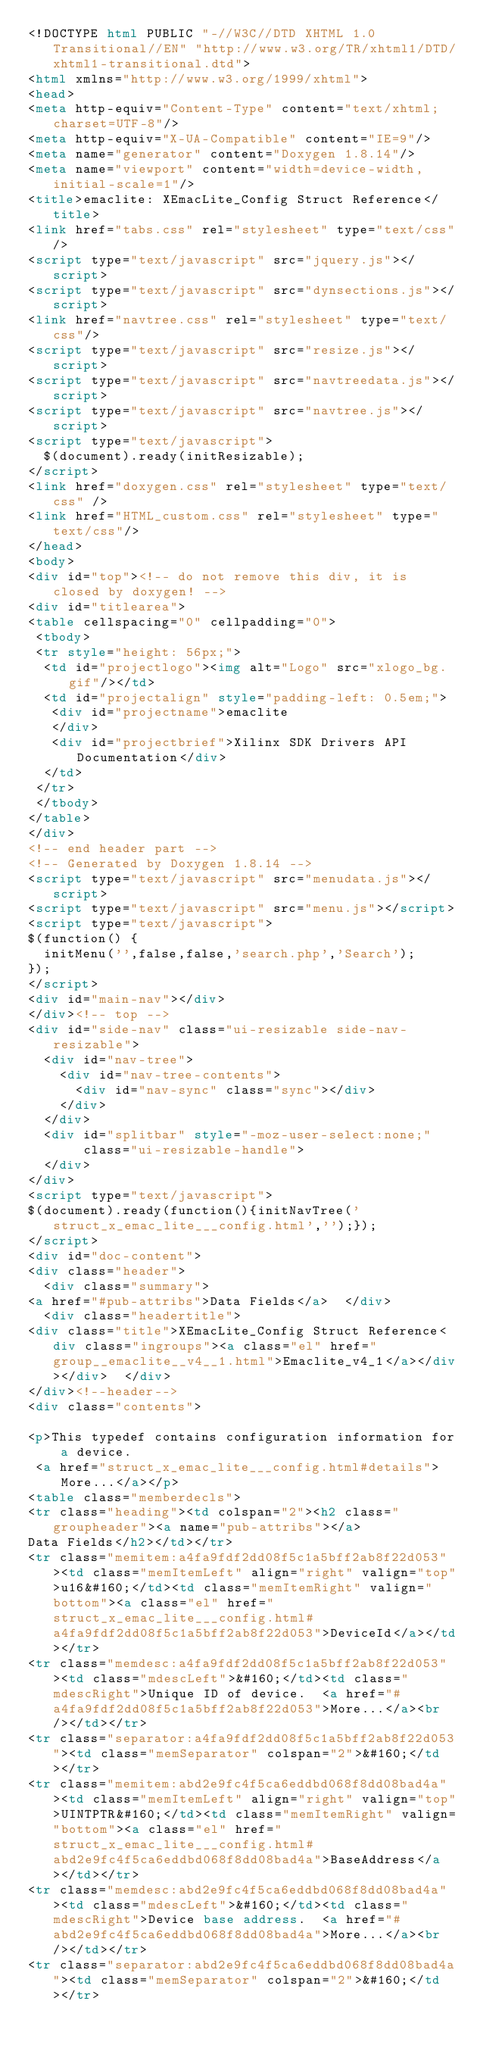<code> <loc_0><loc_0><loc_500><loc_500><_HTML_><!DOCTYPE html PUBLIC "-//W3C//DTD XHTML 1.0 Transitional//EN" "http://www.w3.org/TR/xhtml1/DTD/xhtml1-transitional.dtd">
<html xmlns="http://www.w3.org/1999/xhtml">
<head>
<meta http-equiv="Content-Type" content="text/xhtml;charset=UTF-8"/>
<meta http-equiv="X-UA-Compatible" content="IE=9"/>
<meta name="generator" content="Doxygen 1.8.14"/>
<meta name="viewport" content="width=device-width, initial-scale=1"/>
<title>emaclite: XEmacLite_Config Struct Reference</title>
<link href="tabs.css" rel="stylesheet" type="text/css"/>
<script type="text/javascript" src="jquery.js"></script>
<script type="text/javascript" src="dynsections.js"></script>
<link href="navtree.css" rel="stylesheet" type="text/css"/>
<script type="text/javascript" src="resize.js"></script>
<script type="text/javascript" src="navtreedata.js"></script>
<script type="text/javascript" src="navtree.js"></script>
<script type="text/javascript">
  $(document).ready(initResizable);
</script>
<link href="doxygen.css" rel="stylesheet" type="text/css" />
<link href="HTML_custom.css" rel="stylesheet" type="text/css"/>
</head>
<body>
<div id="top"><!-- do not remove this div, it is closed by doxygen! -->
<div id="titlearea">
<table cellspacing="0" cellpadding="0">
 <tbody>
 <tr style="height: 56px;">
  <td id="projectlogo"><img alt="Logo" src="xlogo_bg.gif"/></td>
  <td id="projectalign" style="padding-left: 0.5em;">
   <div id="projectname">emaclite
   </div>
   <div id="projectbrief">Xilinx SDK Drivers API Documentation</div>
  </td>
 </tr>
 </tbody>
</table>
</div>
<!-- end header part -->
<!-- Generated by Doxygen 1.8.14 -->
<script type="text/javascript" src="menudata.js"></script>
<script type="text/javascript" src="menu.js"></script>
<script type="text/javascript">
$(function() {
  initMenu('',false,false,'search.php','Search');
});
</script>
<div id="main-nav"></div>
</div><!-- top -->
<div id="side-nav" class="ui-resizable side-nav-resizable">
  <div id="nav-tree">
    <div id="nav-tree-contents">
      <div id="nav-sync" class="sync"></div>
    </div>
  </div>
  <div id="splitbar" style="-moz-user-select:none;" 
       class="ui-resizable-handle">
  </div>
</div>
<script type="text/javascript">
$(document).ready(function(){initNavTree('struct_x_emac_lite___config.html','');});
</script>
<div id="doc-content">
<div class="header">
  <div class="summary">
<a href="#pub-attribs">Data Fields</a>  </div>
  <div class="headertitle">
<div class="title">XEmacLite_Config Struct Reference<div class="ingroups"><a class="el" href="group__emaclite__v4__1.html">Emaclite_v4_1</a></div></div>  </div>
</div><!--header-->
<div class="contents">

<p>This typedef contains configuration information for a device.  
 <a href="struct_x_emac_lite___config.html#details">More...</a></p>
<table class="memberdecls">
<tr class="heading"><td colspan="2"><h2 class="groupheader"><a name="pub-attribs"></a>
Data Fields</h2></td></tr>
<tr class="memitem:a4fa9fdf2dd08f5c1a5bff2ab8f22d053"><td class="memItemLeft" align="right" valign="top">u16&#160;</td><td class="memItemRight" valign="bottom"><a class="el" href="struct_x_emac_lite___config.html#a4fa9fdf2dd08f5c1a5bff2ab8f22d053">DeviceId</a></td></tr>
<tr class="memdesc:a4fa9fdf2dd08f5c1a5bff2ab8f22d053"><td class="mdescLeft">&#160;</td><td class="mdescRight">Unique ID of device.  <a href="#a4fa9fdf2dd08f5c1a5bff2ab8f22d053">More...</a><br /></td></tr>
<tr class="separator:a4fa9fdf2dd08f5c1a5bff2ab8f22d053"><td class="memSeparator" colspan="2">&#160;</td></tr>
<tr class="memitem:abd2e9fc4f5ca6eddbd068f8dd08bad4a"><td class="memItemLeft" align="right" valign="top">UINTPTR&#160;</td><td class="memItemRight" valign="bottom"><a class="el" href="struct_x_emac_lite___config.html#abd2e9fc4f5ca6eddbd068f8dd08bad4a">BaseAddress</a></td></tr>
<tr class="memdesc:abd2e9fc4f5ca6eddbd068f8dd08bad4a"><td class="mdescLeft">&#160;</td><td class="mdescRight">Device base address.  <a href="#abd2e9fc4f5ca6eddbd068f8dd08bad4a">More...</a><br /></td></tr>
<tr class="separator:abd2e9fc4f5ca6eddbd068f8dd08bad4a"><td class="memSeparator" colspan="2">&#160;</td></tr></code> 